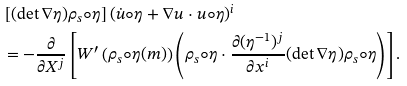Convert formula to latex. <formula><loc_0><loc_0><loc_500><loc_500>& \left [ ( \det \nabla \eta ) \rho _ { s } \circ \eta \right ] ( \dot { u } \circ \eta + \nabla u \cdot u \circ \eta ) ^ { i } \\ & = - \frac { \partial } { \partial X ^ { j } } \left [ W ^ { \prime } \left ( \rho _ { s } \circ \eta ( m ) \right ) \left ( \rho _ { s } \circ \eta \cdot \frac { \partial ( \eta ^ { - 1 } ) ^ { j } } { \partial x ^ { i } } ( \det \nabla \eta ) \rho _ { s } \circ \eta \right ) \right ] .</formula> 